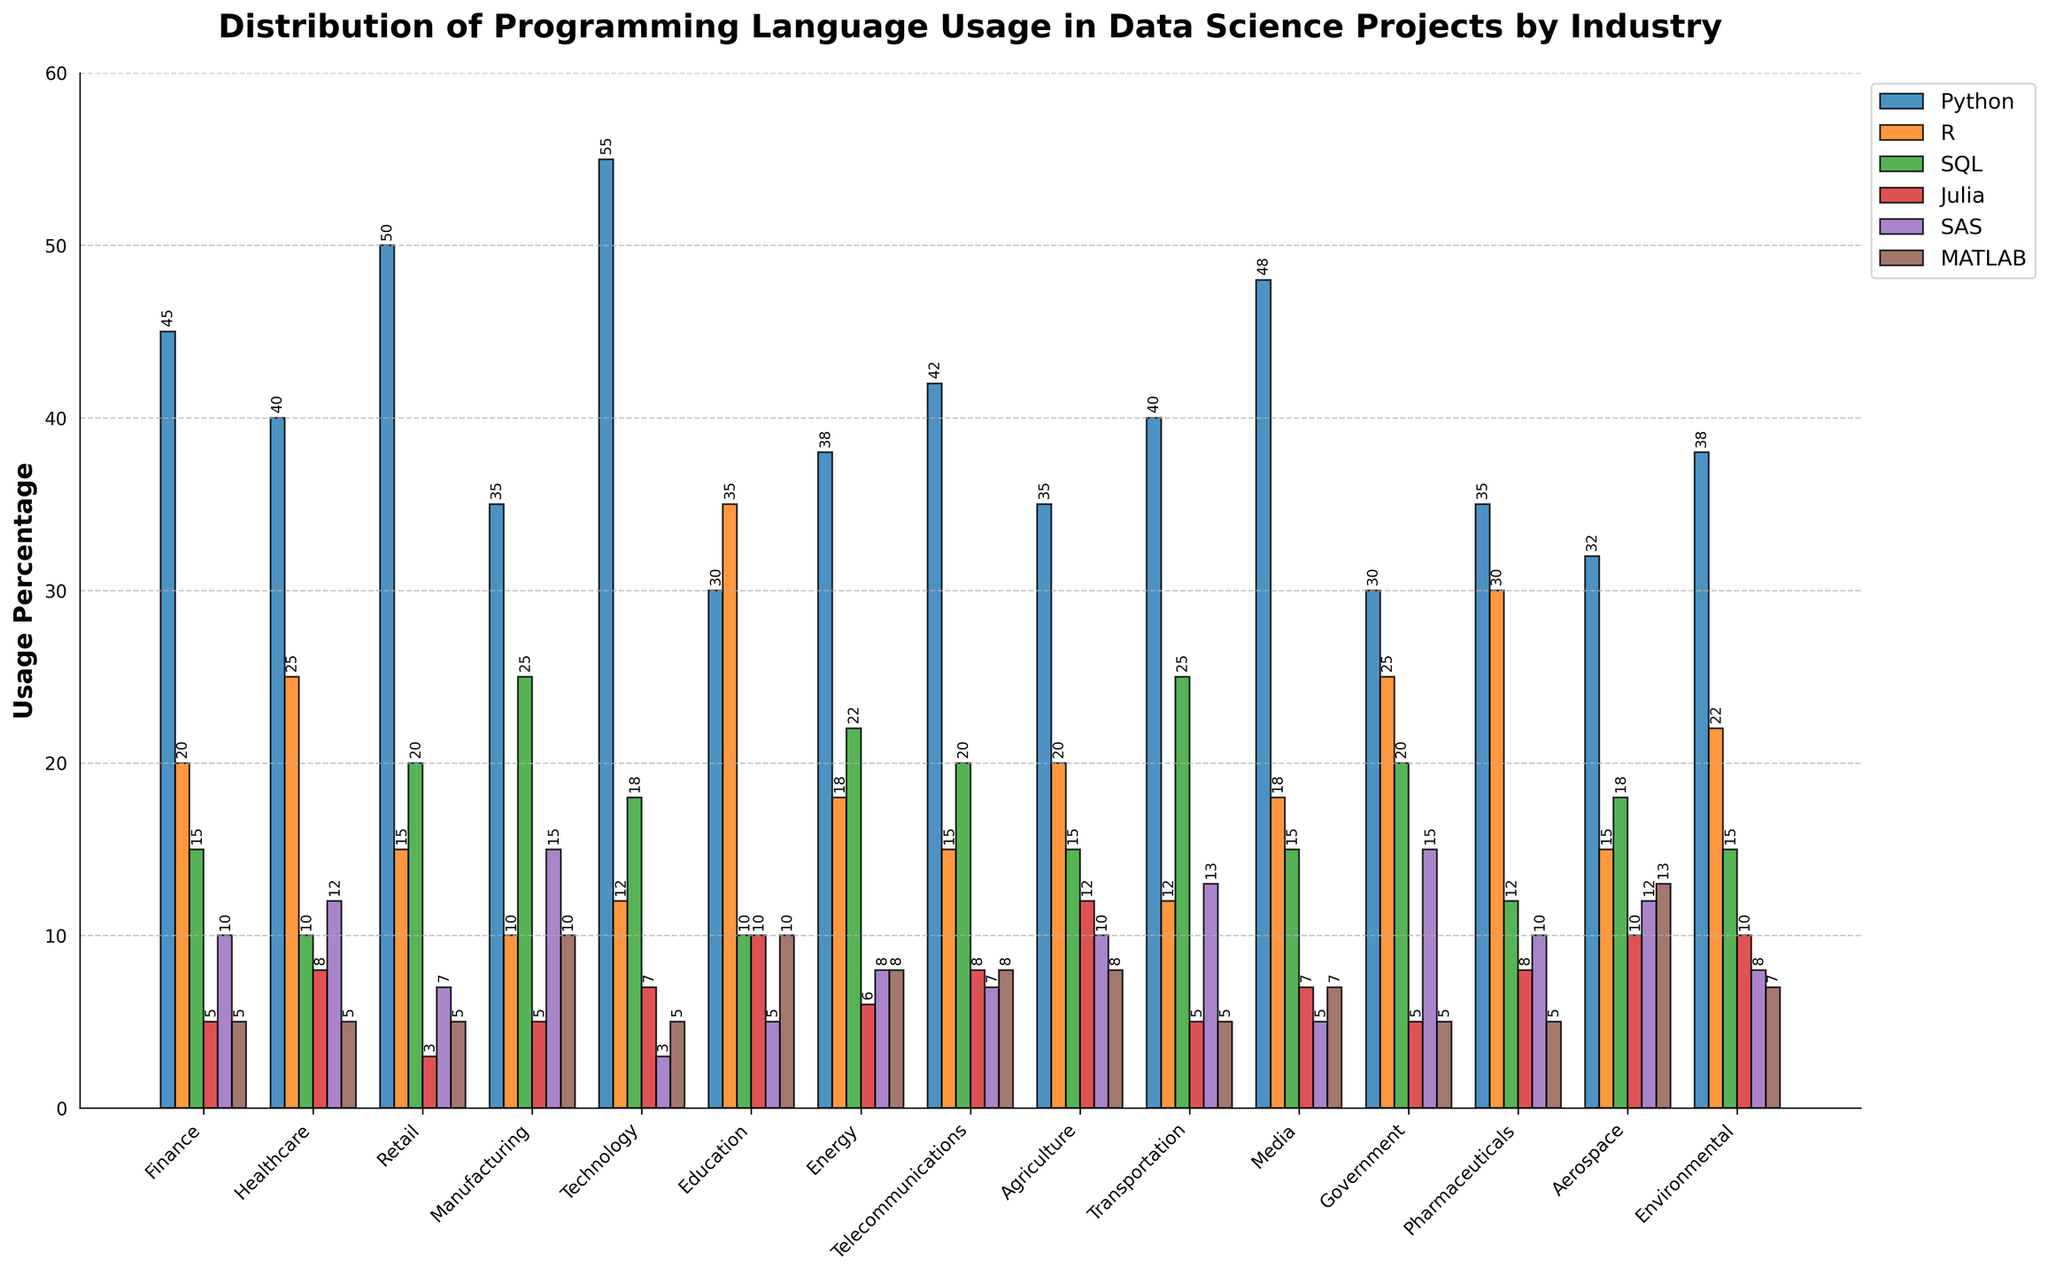Which industry uses Python the most? To answer this, locate the highest bar among the Python bars across all industries. The Technology industry has the highest bar.
Answer: Technology Which two industries use Julia the least? Identify the shortest bars in the Julia category. Retail and Finance have the shortest bars.
Answer: Retail and Finance Does any industry have an equal usage percentage for SAS and MATLAB? Look for industries where the heights of the SAS and MATLAB bars match. Finance is the only industry where the bars for SAS and MATLAB are of equal height.
Answer: Finance How much more prevalent is Python compared to R in the Healthcare industry? Find the Healthcare bars for Python and R, then calculate the difference in height. Python is at 40% and R is at 25%, so the difference is 15%.
Answer: 15% Which industry has the smallest difference in usage percentage between Python and SQL? Calculate the difference between the Python and SQL bars for each industry. For Government, Python is 30% and SQL is 20%, resulting in a difference of 10%, the smallest among all industries.
Answer: Government Rank the top three industries by the usage percentage of SQL. Identify the heights of the SQL bars and order them. Manufacturing (25%), Transportation (25%), and Energy (22%) are the top three.
Answer: Manufacturing, Transportation, and Energy In which industry does Julia have a higher usage percentage than both R and SQL? Locate the Julia bars and see if they exceed both R and SQL in any industry. In Agriculture, Julia (12%) is higher than both R (20%) and SQL (15%).
Answer: Agriculture Which industry uses MATLAB the most, and what is the exact percentage? Look for the highest bar in the MATLAB category. Aerospace has the highest MATLAB bar at 13%.
Answer: Aerospace, 13% How many industries use R more than 20%? Count the R bars that are above the 20% mark. There are four such industries: Healthcare, Education, Pharmaceuticals, and Government.
Answer: Four In how many industries is the usage percentage of SAS lower than 10%? Count the SAS bars that are below the 10% mark. Three industries have less than 10% SAS usage: Technology (3%), Retail (7%), and Telecommunications (7%).
Answer: Three 